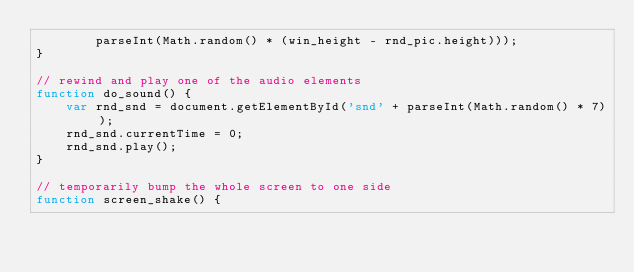Convert code to text. <code><loc_0><loc_0><loc_500><loc_500><_JavaScript_>        parseInt(Math.random() * (win_height - rnd_pic.height)));
}

// rewind and play one of the audio elements
function do_sound() {
    var rnd_snd = document.getElementById('snd' + parseInt(Math.random() * 7));
    rnd_snd.currentTime = 0;
    rnd_snd.play();
}

// temporarily bump the whole screen to one side
function screen_shake() {</code> 